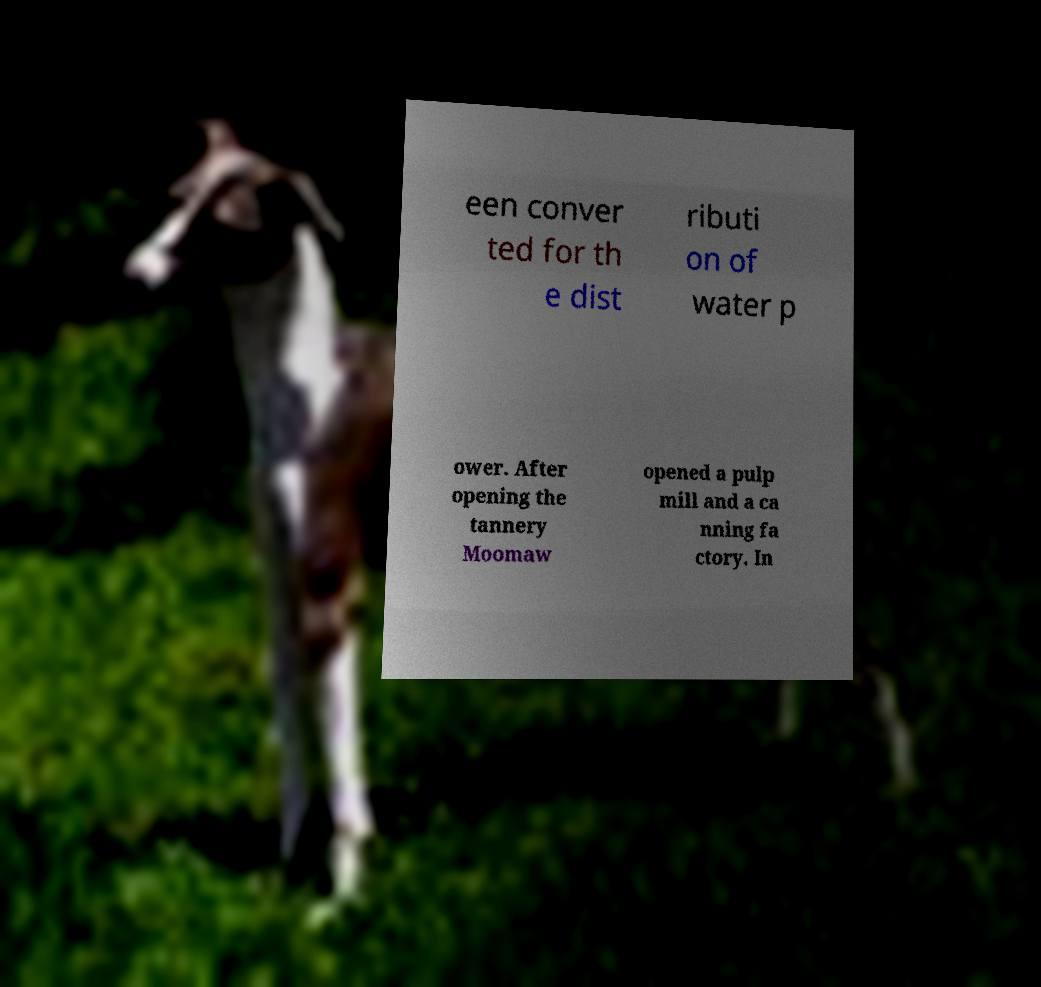Can you read and provide the text displayed in the image?This photo seems to have some interesting text. Can you extract and type it out for me? een conver ted for th e dist ributi on of water p ower. After opening the tannery Moomaw opened a pulp mill and a ca nning fa ctory. In 